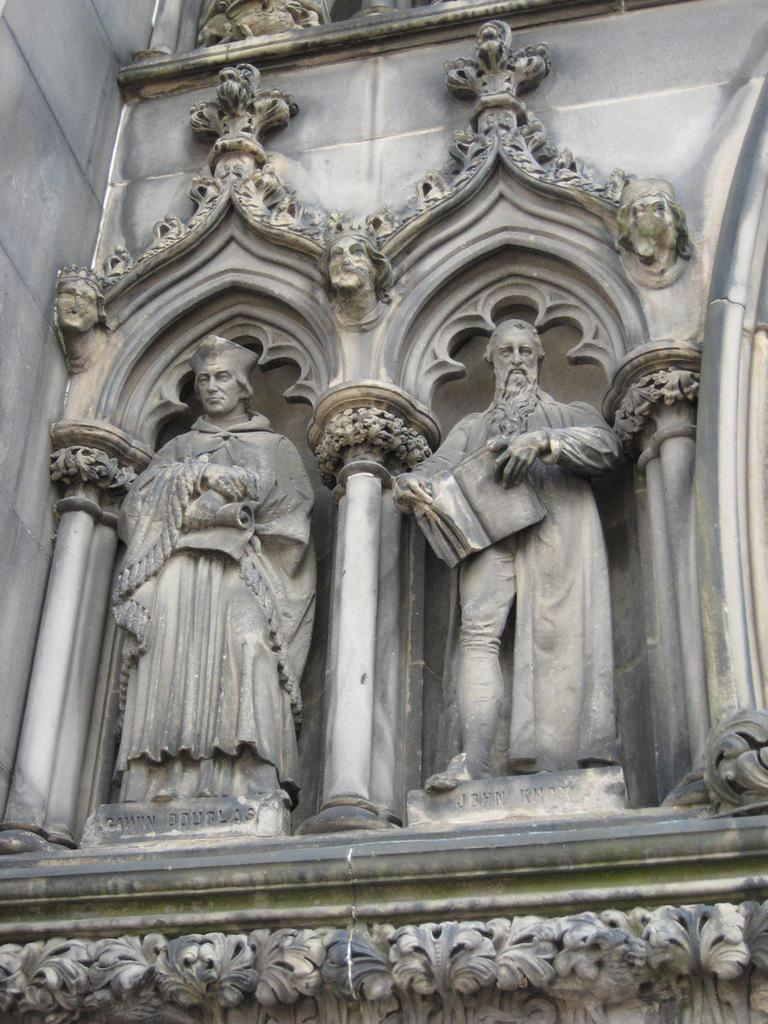What can be seen in the image that resembles human figures? There are two carved statues in the image. What architectural feature is present on the wall in the image? There are arches on the wall in the image. What type of game are the babies playing in the image? There are no babies or games present in the image. Can you tell me what color the cow is in the image? There is no cow present in the image. 